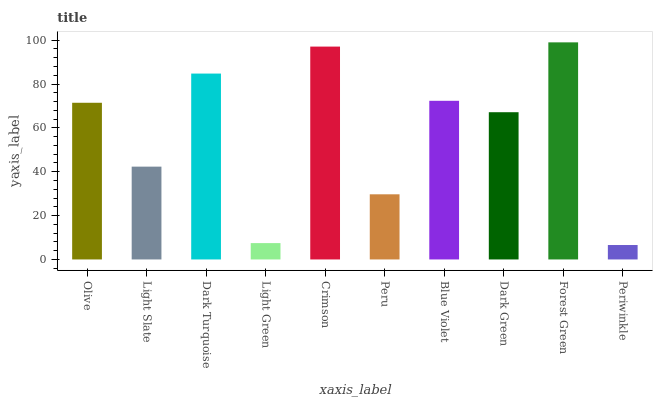Is Periwinkle the minimum?
Answer yes or no. Yes. Is Forest Green the maximum?
Answer yes or no. Yes. Is Light Slate the minimum?
Answer yes or no. No. Is Light Slate the maximum?
Answer yes or no. No. Is Olive greater than Light Slate?
Answer yes or no. Yes. Is Light Slate less than Olive?
Answer yes or no. Yes. Is Light Slate greater than Olive?
Answer yes or no. No. Is Olive less than Light Slate?
Answer yes or no. No. Is Olive the high median?
Answer yes or no. Yes. Is Dark Green the low median?
Answer yes or no. Yes. Is Dark Turquoise the high median?
Answer yes or no. No. Is Periwinkle the low median?
Answer yes or no. No. 